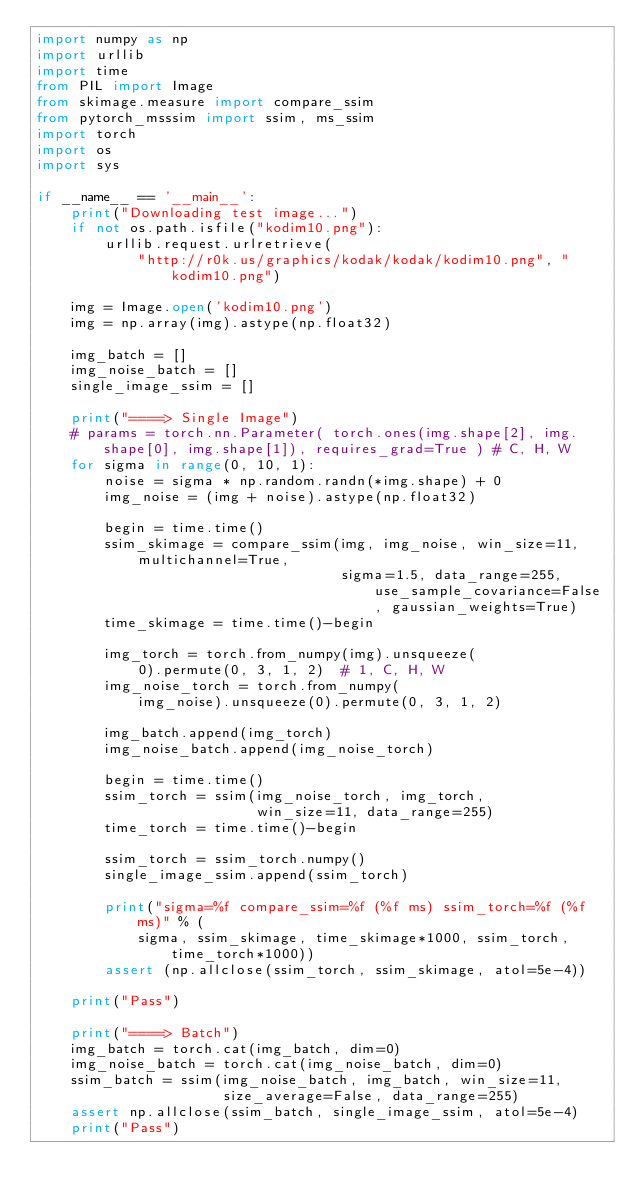Convert code to text. <code><loc_0><loc_0><loc_500><loc_500><_Python_>import numpy as np
import urllib
import time
from PIL import Image
from skimage.measure import compare_ssim
from pytorch_msssim import ssim, ms_ssim
import torch
import os
import sys

if __name__ == '__main__':
    print("Downloading test image...")
    if not os.path.isfile("kodim10.png"):
        urllib.request.urlretrieve(
            "http://r0k.us/graphics/kodak/kodak/kodim10.png", "kodim10.png")

    img = Image.open('kodim10.png')
    img = np.array(img).astype(np.float32)

    img_batch = []
    img_noise_batch = []
    single_image_ssim = []

    print("====> Single Image")
    # params = torch.nn.Parameter( torch.ones(img.shape[2], img.shape[0], img.shape[1]), requires_grad=True ) # C, H, W
    for sigma in range(0, 10, 1):
        noise = sigma * np.random.randn(*img.shape) + 0
        img_noise = (img + noise).astype(np.float32)

        begin = time.time()
        ssim_skimage = compare_ssim(img, img_noise, win_size=11, multichannel=True,
                                    sigma=1.5, data_range=255, use_sample_covariance=False, gaussian_weights=True)
        time_skimage = time.time()-begin

        img_torch = torch.from_numpy(img).unsqueeze(
            0).permute(0, 3, 1, 2)  # 1, C, H, W
        img_noise_torch = torch.from_numpy(
            img_noise).unsqueeze(0).permute(0, 3, 1, 2)

        img_batch.append(img_torch)
        img_noise_batch.append(img_noise_torch)

        begin = time.time()
        ssim_torch = ssim(img_noise_torch, img_torch,
                          win_size=11, data_range=255)
        time_torch = time.time()-begin

        ssim_torch = ssim_torch.numpy()
        single_image_ssim.append(ssim_torch)

        print("sigma=%f compare_ssim=%f (%f ms) ssim_torch=%f (%f ms)" % (
            sigma, ssim_skimage, time_skimage*1000, ssim_torch, time_torch*1000))
        assert (np.allclose(ssim_torch, ssim_skimage, atol=5e-4))

    print("Pass")

    print("====> Batch")
    img_batch = torch.cat(img_batch, dim=0)
    img_noise_batch = torch.cat(img_noise_batch, dim=0)
    ssim_batch = ssim(img_noise_batch, img_batch, win_size=11,
                      size_average=False, data_range=255)
    assert np.allclose(ssim_batch, single_image_ssim, atol=5e-4)
    print("Pass")
</code> 